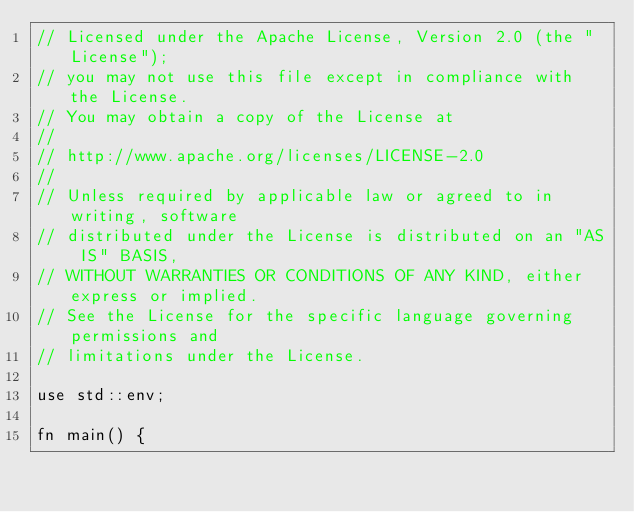<code> <loc_0><loc_0><loc_500><loc_500><_Rust_>// Licensed under the Apache License, Version 2.0 (the "License");
// you may not use this file except in compliance with the License.
// You may obtain a copy of the License at
//
// http://www.apache.org/licenses/LICENSE-2.0
//
// Unless required by applicable law or agreed to in writing, software
// distributed under the License is distributed on an "AS IS" BASIS,
// WITHOUT WARRANTIES OR CONDITIONS OF ANY KIND, either express or implied.
// See the License for the specific language governing permissions and
// limitations under the License.

use std::env;

fn main() {</code> 